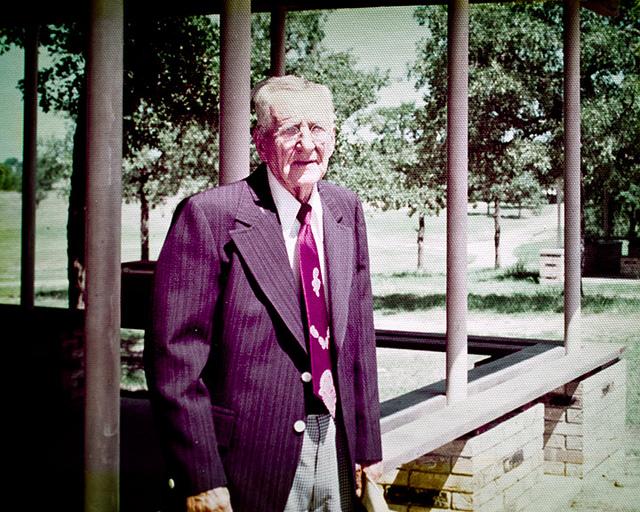Is this a young man?
Short answer required. No. Is this man wearing glasses?
Write a very short answer. Yes. What color is the man's tie?
Short answer required. Purple. Is the man dressed in a business suit?
Short answer required. Yes. What color shirt is the man wearing?
Write a very short answer. White. 